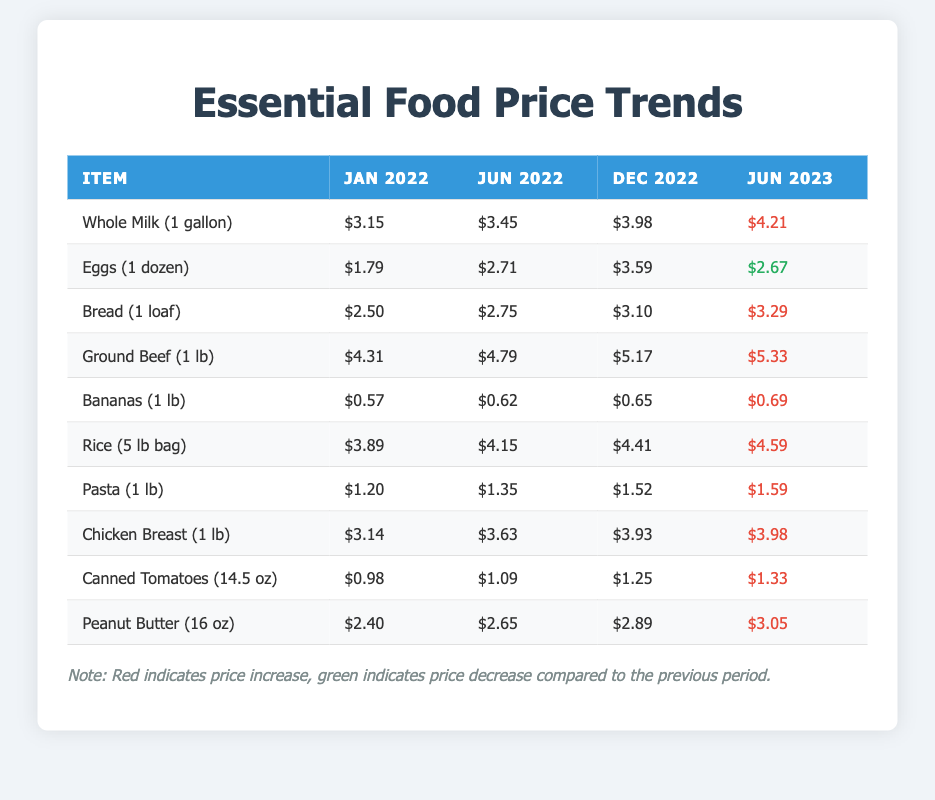What is the price of whole milk in June 2023? The table shows that the price of whole milk in June 2023 is listed under the corresponding column. Looking at the row for whole milk, we can see the price is $4.21.
Answer: $4.21 Which food item had the highest price in December 2022? In December 2022, we can review the prices of all food items listed in the table. The highest price appears to be for ground beef at $5.17.
Answer: Ground Beef (1 lb) What was the total price increase for bananas from January 2022 to June 2023? The price of bananas in January 2022 is $0.57 and in June 2023 is $0.69. To calculate the total price increase, we subtract the January price from the June price: $0.69 - $0.57 = $0.12.
Answer: $0.12 Did the price of eggs decrease from December 2022 to June 2023? By comparing the prices, we note that in December 2022, eggs were $3.59, while in June 2023, the price is $2.67. Since $2.67 is less than $3.59, there was a decrease.
Answer: Yes What is the average price of pasta across all time points listed? The prices for pasta are: $1.20 (Jan 2022), $1.35 (Jun 2022), $1.52 (Dec 2022), and $1.59 (Jun 2023). To find the average, we sum: 1.20 + 1.35 + 1.52 + 1.59 = 5.66, then divide by 4: 5.66 / 4 = 1.415.
Answer: $1.42 